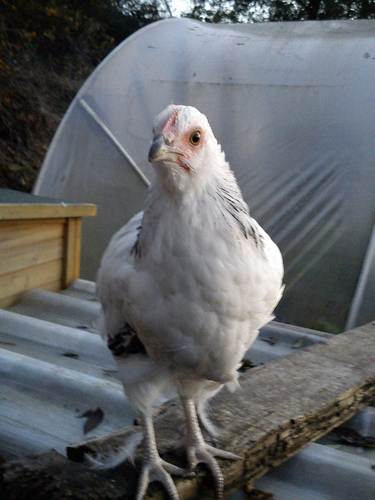<image>
Can you confirm if the wood is on the bird? No. The wood is not positioned on the bird. They may be near each other, but the wood is not supported by or resting on top of the bird. Is there a chicken in front of the feather? Yes. The chicken is positioned in front of the feather, appearing closer to the camera viewpoint. 